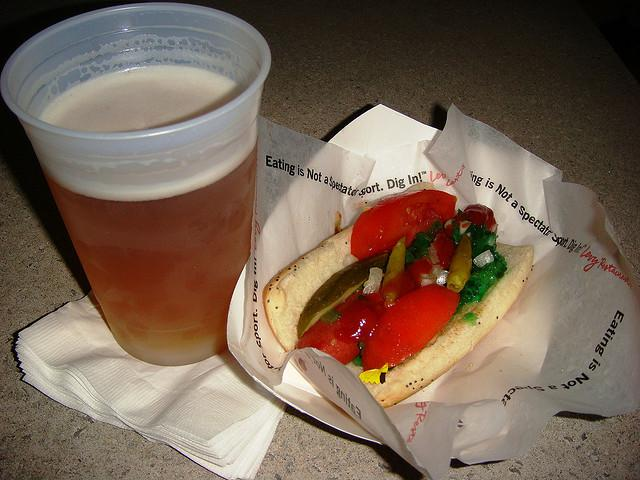What celebrity has a first name that is the same name as the red item in this tomato free sandwich? Please explain your reasoning. pepper keenan. The red item is a pepper and answer a is a person whose first name is also pepper. 